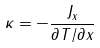<formula> <loc_0><loc_0><loc_500><loc_500>\kappa = - \frac { J _ { x } } { \partial T / \partial x }</formula> 